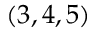<formula> <loc_0><loc_0><loc_500><loc_500>\left ( 3 , 4 , 5 \right )</formula> 